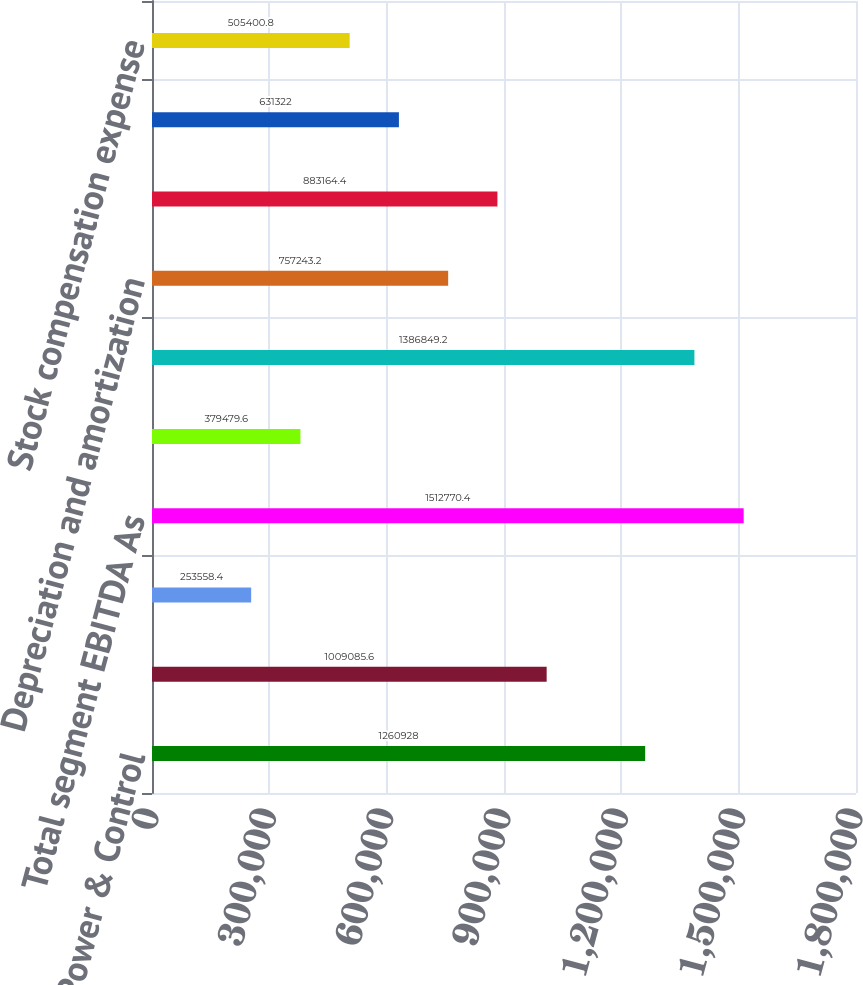Convert chart to OTSL. <chart><loc_0><loc_0><loc_500><loc_500><bar_chart><fcel>Power & Control<fcel>Airframe<fcel>Non-aviation<fcel>Total segment EBITDA As<fcel>Unallocated corporate expenses<fcel>Total Company EBITDA As<fcel>Depreciation and amortization<fcel>Interest expense net<fcel>Acquisition-related costs<fcel>Stock compensation expense<nl><fcel>1.26093e+06<fcel>1.00909e+06<fcel>253558<fcel>1.51277e+06<fcel>379480<fcel>1.38685e+06<fcel>757243<fcel>883164<fcel>631322<fcel>505401<nl></chart> 